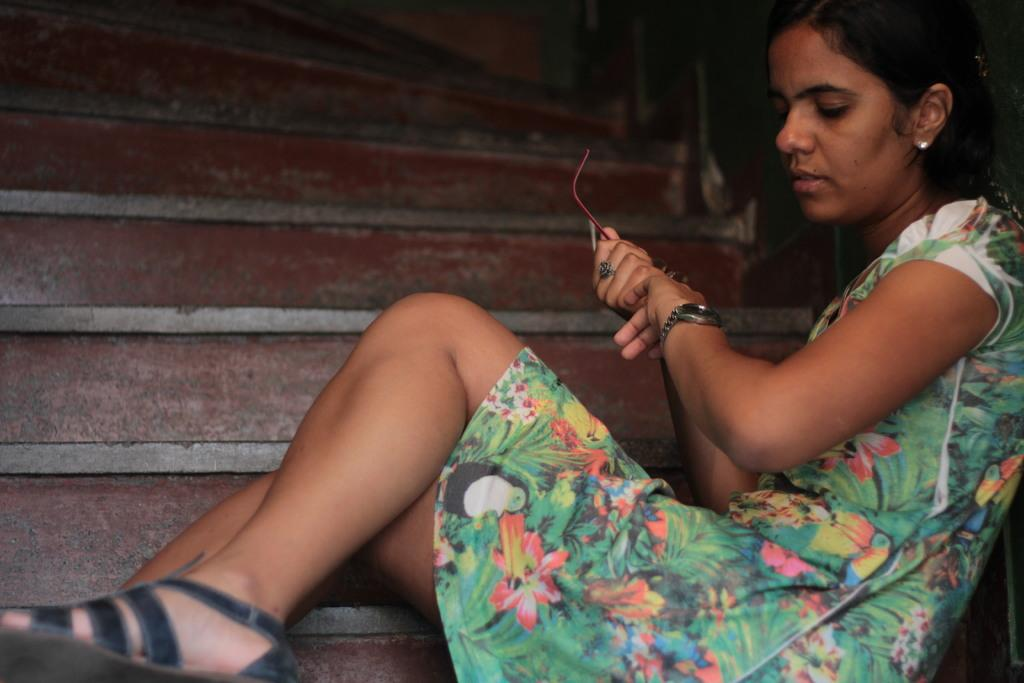Who is present in the image? There is a woman in the image. What is the woman doing in the image? The woman is sitting on the stairs. What is the woman holding in her hand? The woman is holding spectacles in her hand. What accessory is the woman wearing? The woman is wearing a watch. Where can the tomatoes be found in the image? There are no tomatoes present in the image. How many brothers does the woman have in the image? There is no information about the woman's brothers in the image. 